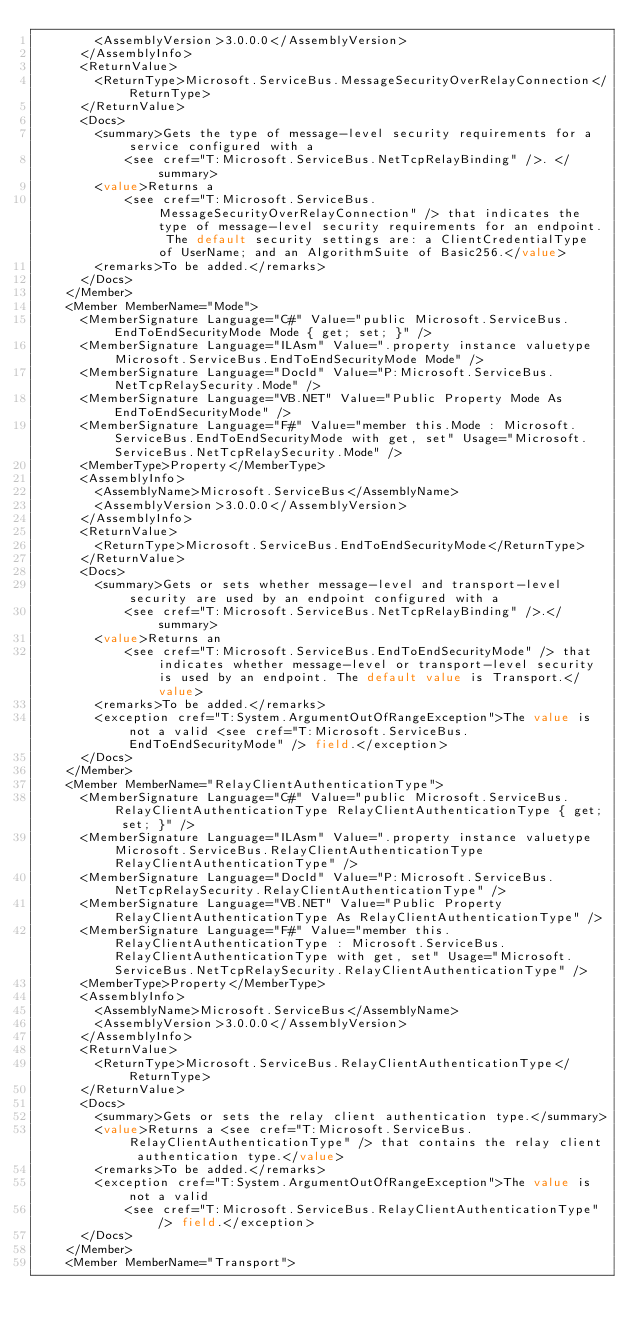<code> <loc_0><loc_0><loc_500><loc_500><_XML_>        <AssemblyVersion>3.0.0.0</AssemblyVersion>
      </AssemblyInfo>
      <ReturnValue>
        <ReturnType>Microsoft.ServiceBus.MessageSecurityOverRelayConnection</ReturnType>
      </ReturnValue>
      <Docs>
        <summary>Gets the type of message-level security requirements for a service configured with a 
            <see cref="T:Microsoft.ServiceBus.NetTcpRelayBinding" />. </summary>
        <value>Returns a 
            <see cref="T:Microsoft.ServiceBus.MessageSecurityOverRelayConnection" /> that indicates the type of message-level security requirements for an endpoint. The default security settings are: a ClientCredentialType of UserName; and an AlgorithmSuite of Basic256.</value>
        <remarks>To be added.</remarks>
      </Docs>
    </Member>
    <Member MemberName="Mode">
      <MemberSignature Language="C#" Value="public Microsoft.ServiceBus.EndToEndSecurityMode Mode { get; set; }" />
      <MemberSignature Language="ILAsm" Value=".property instance valuetype Microsoft.ServiceBus.EndToEndSecurityMode Mode" />
      <MemberSignature Language="DocId" Value="P:Microsoft.ServiceBus.NetTcpRelaySecurity.Mode" />
      <MemberSignature Language="VB.NET" Value="Public Property Mode As EndToEndSecurityMode" />
      <MemberSignature Language="F#" Value="member this.Mode : Microsoft.ServiceBus.EndToEndSecurityMode with get, set" Usage="Microsoft.ServiceBus.NetTcpRelaySecurity.Mode" />
      <MemberType>Property</MemberType>
      <AssemblyInfo>
        <AssemblyName>Microsoft.ServiceBus</AssemblyName>
        <AssemblyVersion>3.0.0.0</AssemblyVersion>
      </AssemblyInfo>
      <ReturnValue>
        <ReturnType>Microsoft.ServiceBus.EndToEndSecurityMode</ReturnType>
      </ReturnValue>
      <Docs>
        <summary>Gets or sets whether message-level and transport-level security are used by an endpoint configured with a 
            <see cref="T:Microsoft.ServiceBus.NetTcpRelayBinding" />.</summary>
        <value>Returns an 
            <see cref="T:Microsoft.ServiceBus.EndToEndSecurityMode" /> that indicates whether message-level or transport-level security is used by an endpoint. The default value is Transport.</value>
        <remarks>To be added.</remarks>
        <exception cref="T:System.ArgumentOutOfRangeException">The value is not a valid <see cref="T:Microsoft.ServiceBus.EndToEndSecurityMode" /> field.</exception>
      </Docs>
    </Member>
    <Member MemberName="RelayClientAuthenticationType">
      <MemberSignature Language="C#" Value="public Microsoft.ServiceBus.RelayClientAuthenticationType RelayClientAuthenticationType { get; set; }" />
      <MemberSignature Language="ILAsm" Value=".property instance valuetype Microsoft.ServiceBus.RelayClientAuthenticationType RelayClientAuthenticationType" />
      <MemberSignature Language="DocId" Value="P:Microsoft.ServiceBus.NetTcpRelaySecurity.RelayClientAuthenticationType" />
      <MemberSignature Language="VB.NET" Value="Public Property RelayClientAuthenticationType As RelayClientAuthenticationType" />
      <MemberSignature Language="F#" Value="member this.RelayClientAuthenticationType : Microsoft.ServiceBus.RelayClientAuthenticationType with get, set" Usage="Microsoft.ServiceBus.NetTcpRelaySecurity.RelayClientAuthenticationType" />
      <MemberType>Property</MemberType>
      <AssemblyInfo>
        <AssemblyName>Microsoft.ServiceBus</AssemblyName>
        <AssemblyVersion>3.0.0.0</AssemblyVersion>
      </AssemblyInfo>
      <ReturnValue>
        <ReturnType>Microsoft.ServiceBus.RelayClientAuthenticationType</ReturnType>
      </ReturnValue>
      <Docs>
        <summary>Gets or sets the relay client authentication type.</summary>
        <value>Returns a <see cref="T:Microsoft.ServiceBus.RelayClientAuthenticationType" /> that contains the relay client authentication type.</value>
        <remarks>To be added.</remarks>
        <exception cref="T:System.ArgumentOutOfRangeException">The value is not a valid 
            <see cref="T:Microsoft.ServiceBus.RelayClientAuthenticationType" /> field.</exception>
      </Docs>
    </Member>
    <Member MemberName="Transport"></code> 